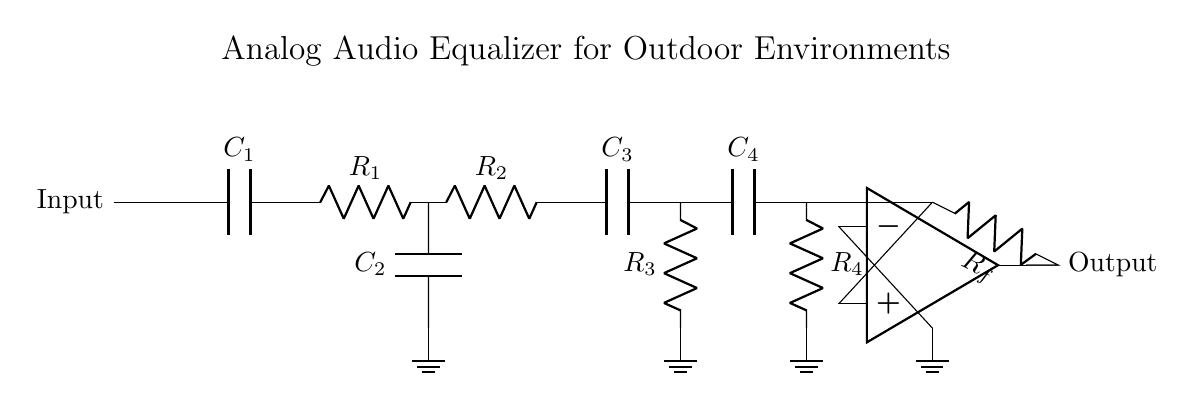What is the primary function of this circuit? The primary function of the circuit is to enhance sound quality by filtering audio frequencies, which is achieved through the use of different filter stages (low-pass, band-pass, high-pass).
Answer: Enhance sound quality What type of components are used in the filtering stages? The filtering stages consist of resistors and capacitors. Resistors are denoted as R and capacitors as C in the diagram. For this circuit, there are four resistors and four capacitors used.
Answer: Resistors and capacitors How many levels of filtering does this circuit provide? The circuit diagram shows a total of three distinct filtering stages: a low-pass filter, a band-pass filter, and a high-pass filter.
Answer: Three levels What is the configuration of the operational amplifier in this circuit? The operational amplifier is configured as a non-inverting amplifier, as it receives the input signal on its non-inverting terminal and has feedback from its output to the inverting terminal.
Answer: Non-inverting amplifier Which component helps to adjust the feedback in the op-amp stage? The feedback in the op-amp stage is adjusted by the resistor labeled Rf, which is connected from the output of the op-amp back to its inverting terminal.
Answer: Resistor Rf What type of audio equalization does this circuit facilitate? The circuit facilitates analog audio equalization, specifically for enhancing frequencies for better clarity and quality in outdoor environments.
Answer: Analog audio equalization What is the purpose of using a band-pass filter here? The band-pass filter allows a specific range of frequencies to pass while attenuating frequencies that are below and above that range, which is important for enhancing conversations or sounds in outdoor settings.
Answer: Enhance specific frequency range 